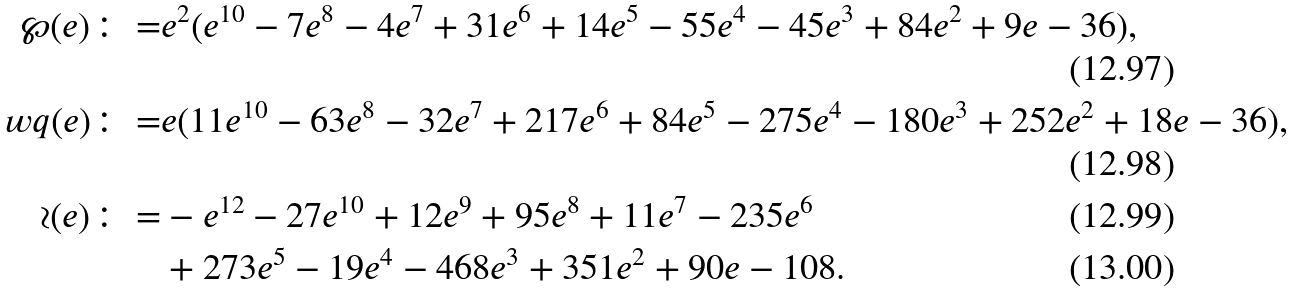Convert formula to latex. <formula><loc_0><loc_0><loc_500><loc_500>\wp ( e ) \colon = & e ^ { 2 } ( e ^ { 1 0 } - 7 e ^ { 8 } - 4 e ^ { 7 } + 3 1 e ^ { 6 } + 1 4 e ^ { 5 } - 5 5 e ^ { 4 } - 4 5 e ^ { 3 } + 8 4 e ^ { 2 } + 9 e - 3 6 ) , \\ \ w q ( e ) \colon = & e ( 1 1 e ^ { 1 0 } - 6 3 e ^ { 8 } - 3 2 e ^ { 7 } + 2 1 7 e ^ { 6 } + 8 4 e ^ { 5 } - 2 7 5 e ^ { 4 } - 1 8 0 e ^ { 3 } + 2 5 2 e ^ { 2 } + 1 8 e - 3 6 ) , \\ \wr ( e ) \colon = & - e ^ { 1 2 } - 2 7 e ^ { 1 0 } + 1 2 e ^ { 9 } + 9 5 e ^ { 8 } + 1 1 e ^ { 7 } - 2 3 5 e ^ { 6 } \\ & + 2 7 3 e ^ { 5 } - 1 9 e ^ { 4 } - 4 6 8 e ^ { 3 } + 3 5 1 e ^ { 2 } + 9 0 e - 1 0 8 .</formula> 